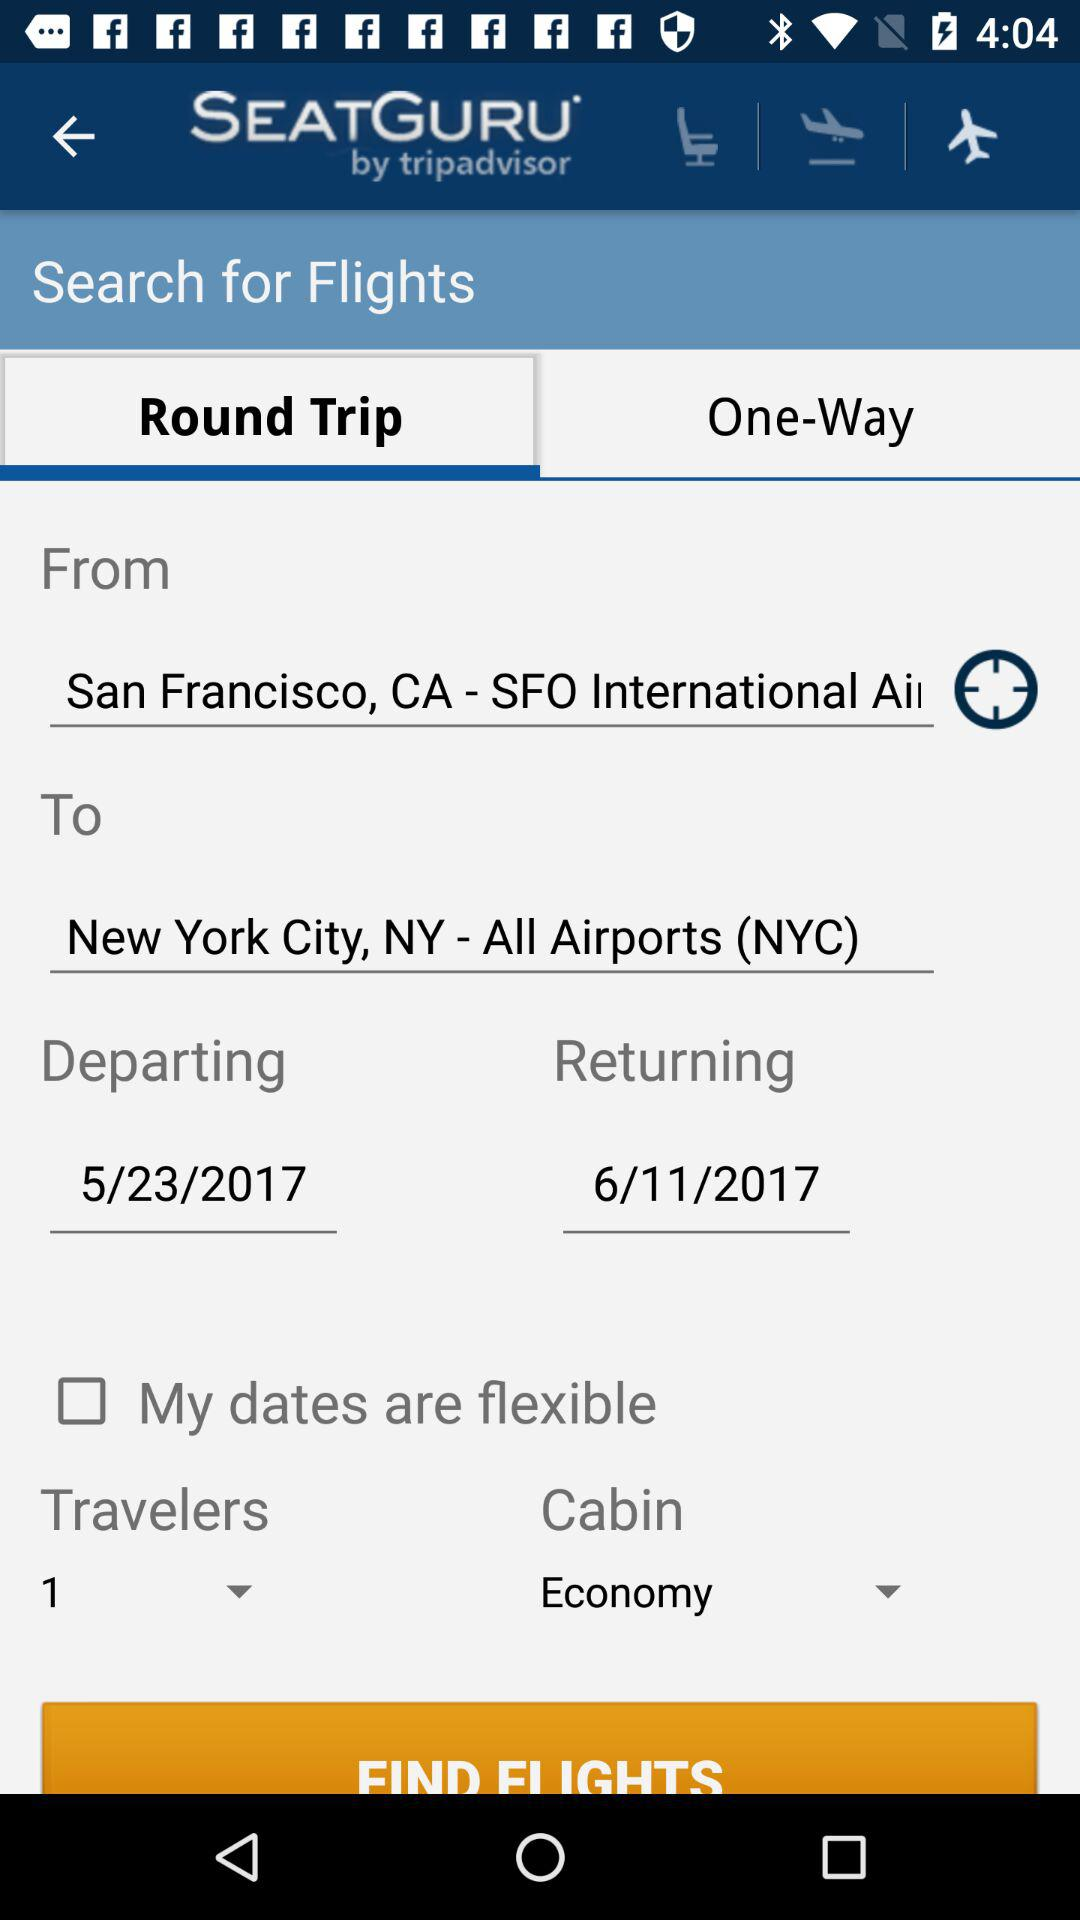How many passengers are there?
Answer the question using a single word or phrase. 1 